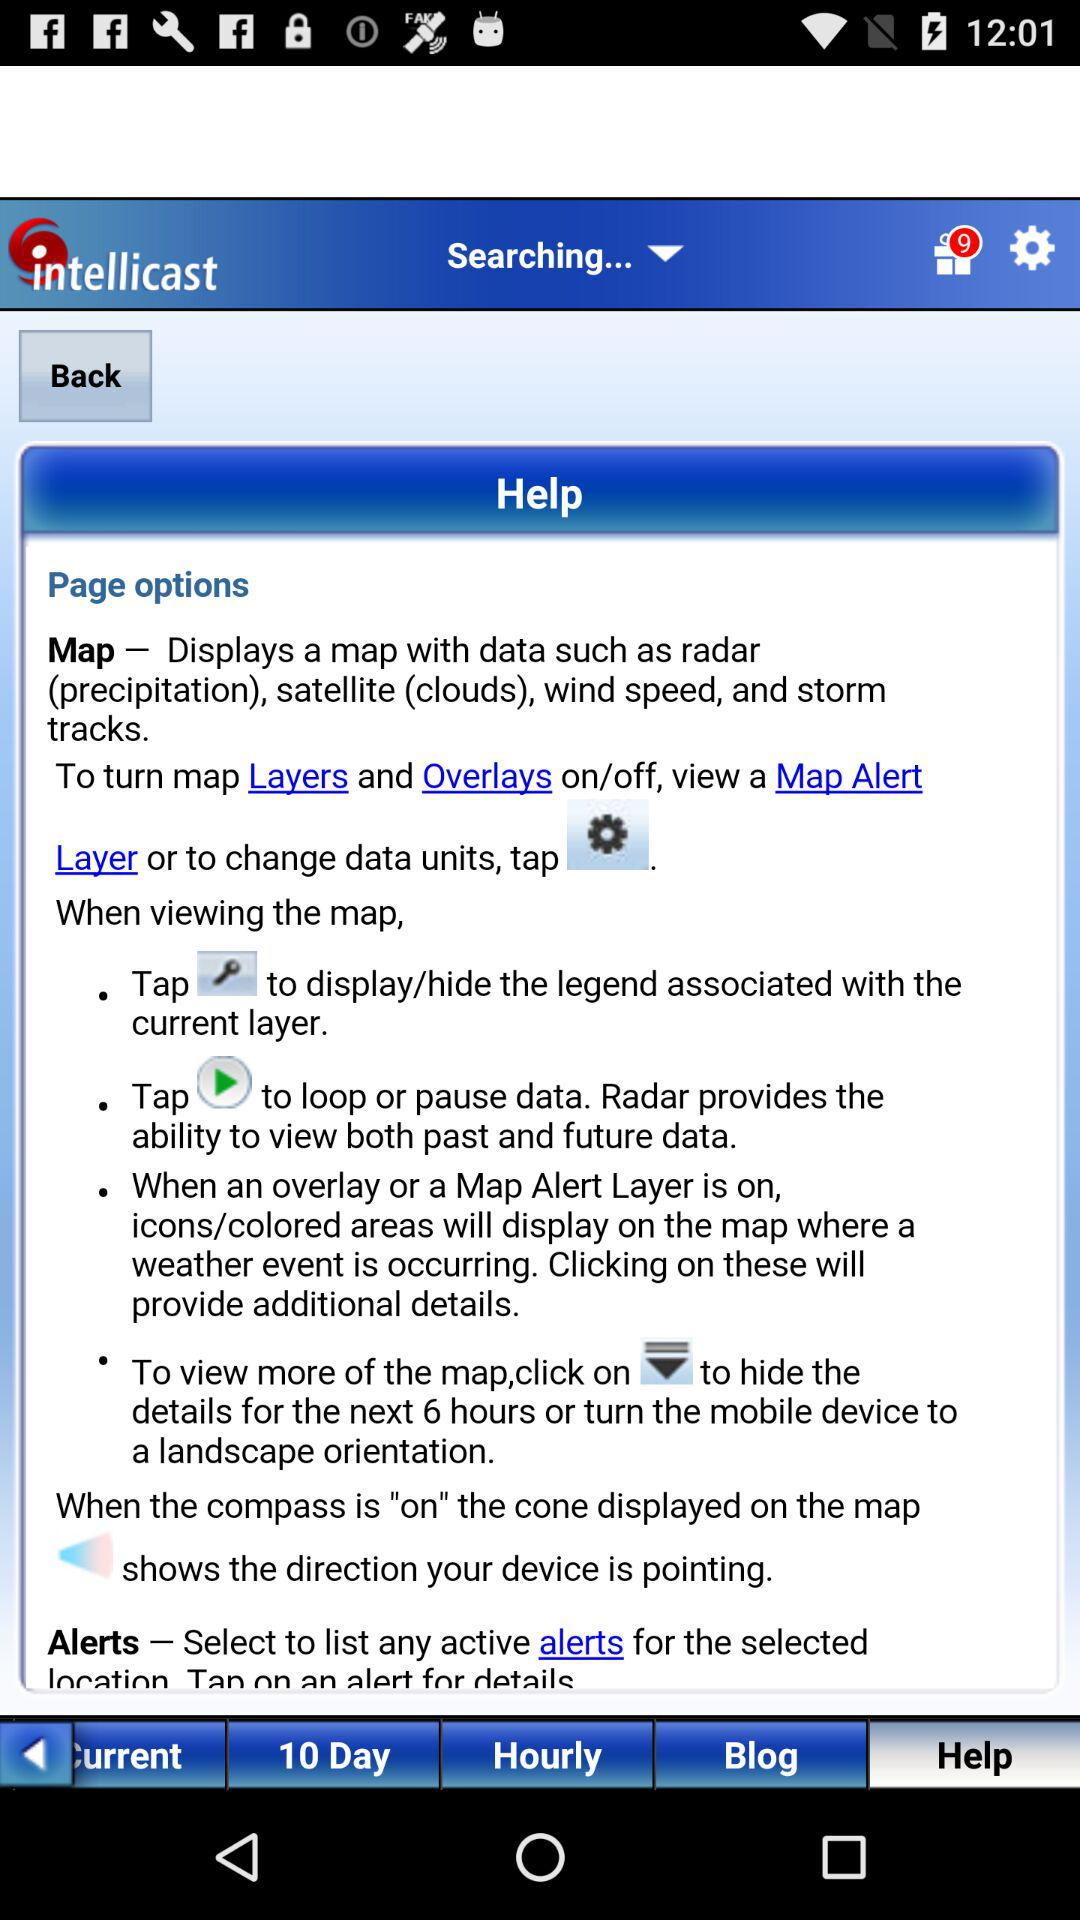Which tab is selected in the taskbar? The selected tab is "Help". 